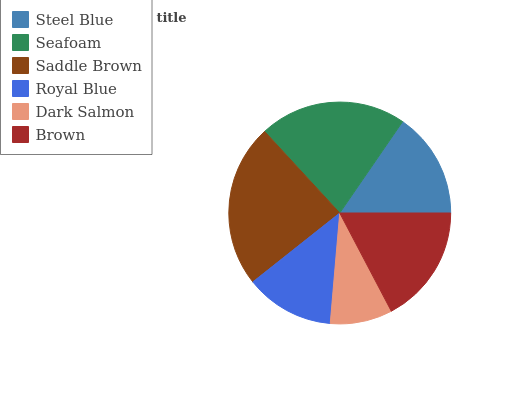Is Dark Salmon the minimum?
Answer yes or no. Yes. Is Saddle Brown the maximum?
Answer yes or no. Yes. Is Seafoam the minimum?
Answer yes or no. No. Is Seafoam the maximum?
Answer yes or no. No. Is Seafoam greater than Steel Blue?
Answer yes or no. Yes. Is Steel Blue less than Seafoam?
Answer yes or no. Yes. Is Steel Blue greater than Seafoam?
Answer yes or no. No. Is Seafoam less than Steel Blue?
Answer yes or no. No. Is Brown the high median?
Answer yes or no. Yes. Is Steel Blue the low median?
Answer yes or no. Yes. Is Royal Blue the high median?
Answer yes or no. No. Is Saddle Brown the low median?
Answer yes or no. No. 